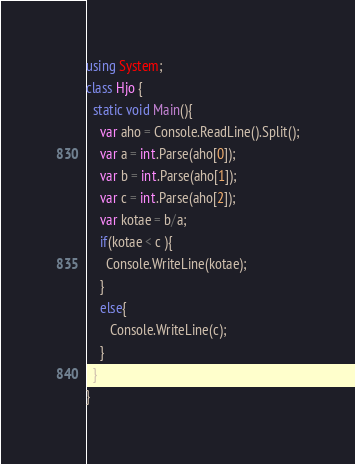<code> <loc_0><loc_0><loc_500><loc_500><_C#_>using System;
class Hjo {
  static void Main(){
    var aho = Console.ReadLine().Split();
    var a = int.Parse(aho[0]);
    var b = int.Parse(aho[1]);
    var c = int.Parse(aho[2]);
    var kotae = b/a;
    if(kotae < c ){
      Console.WriteLine(kotae);
    }
    else{
       Console.WriteLine(c);
    }
  }
}</code> 